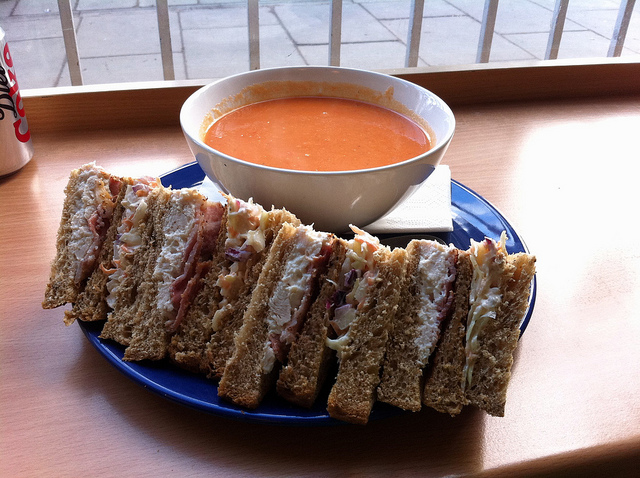Which ingredients can I see in the sandwich sections? In the sandwich sections, you can see layers of meat that could be turkey or chicken, bacon strips, mayonnaise, lettuce, and possibly tomato, all placed between slices of toasted bread. Could you suggest a beverage to pair with this meal? A classic pairing with a club sandwich and tomato soup might be unsweetened iced tea, which would complement the flavors without overpowering them. For a warming option, a light-bodied but flavorful herbal tea, like chamomile or mint, could also be pleasant. 